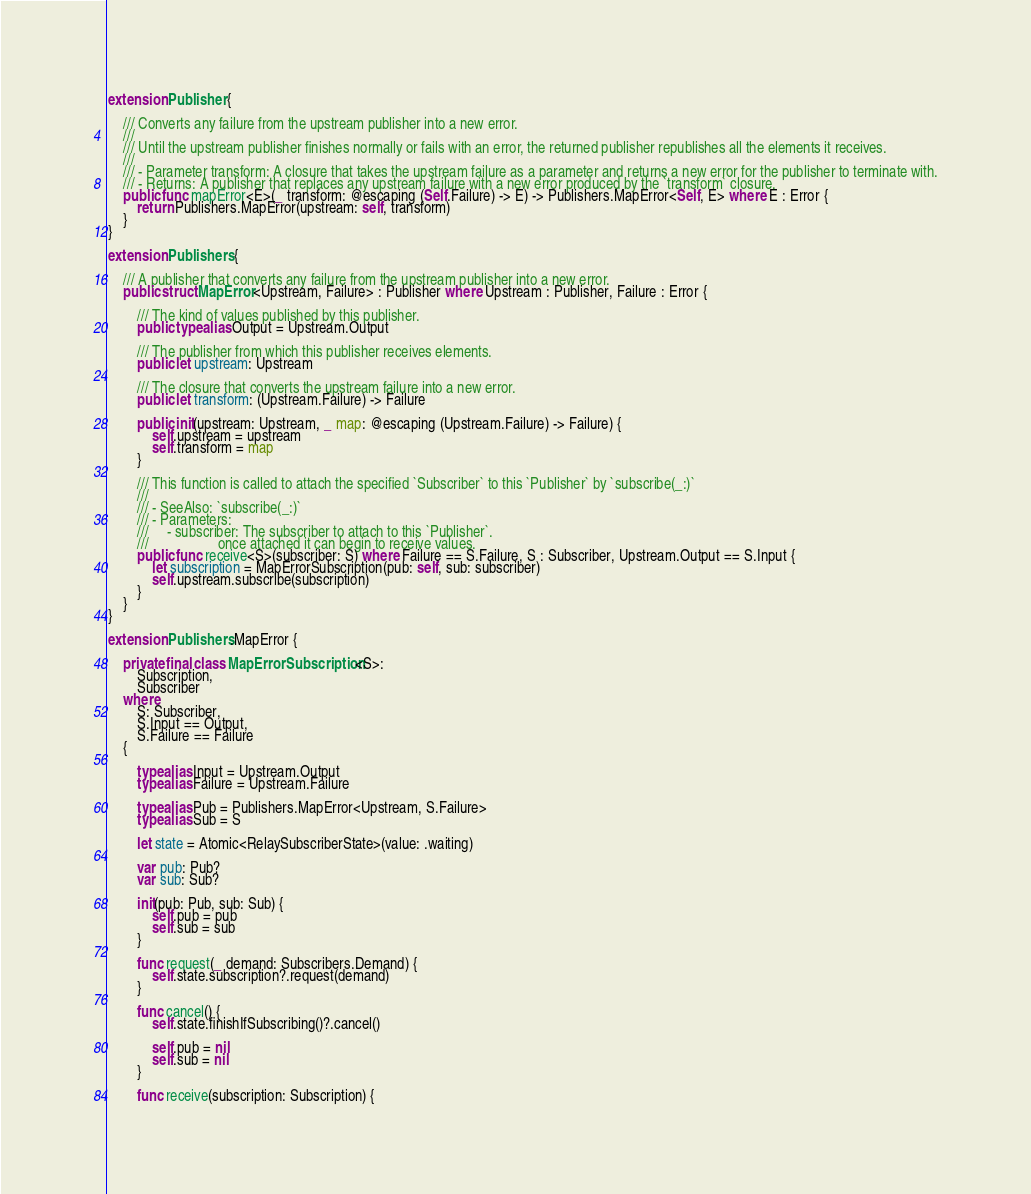<code> <loc_0><loc_0><loc_500><loc_500><_Swift_>extension Publisher {
    
    /// Converts any failure from the upstream publisher into a new error.
    ///
    /// Until the upstream publisher finishes normally or fails with an error, the returned publisher republishes all the elements it receives.
    ///
    /// - Parameter transform: A closure that takes the upstream failure as a parameter and returns a new error for the publisher to terminate with.
    /// - Returns: A publisher that replaces any upstream failure with a new error produced by the `transform` closure.
    public func mapError<E>(_ transform: @escaping (Self.Failure) -> E) -> Publishers.MapError<Self, E> where E : Error {
        return Publishers.MapError(upstream: self, transform)
    }
}

extension Publishers {
    
    /// A publisher that converts any failure from the upstream publisher into a new error.
    public struct MapError<Upstream, Failure> : Publisher where Upstream : Publisher, Failure : Error {
        
        /// The kind of values published by this publisher.
        public typealias Output = Upstream.Output
        
        /// The publisher from which this publisher receives elements.
        public let upstream: Upstream
        
        /// The closure that converts the upstream failure into a new error.
        public let transform: (Upstream.Failure) -> Failure
        
        public init(upstream: Upstream, _ map: @escaping (Upstream.Failure) -> Failure) {
            self.upstream = upstream
            self.transform = map
        }
        
        /// This function is called to attach the specified `Subscriber` to this `Publisher` by `subscribe(_:)`
        ///
        /// - SeeAlso: `subscribe(_:)`
        /// - Parameters:
        ///     - subscriber: The subscriber to attach to this `Publisher`.
        ///                   once attached it can begin to receive values.
        public func receive<S>(subscriber: S) where Failure == S.Failure, S : Subscriber, Upstream.Output == S.Input {
            let subscription = MapErrorSubscription(pub: self, sub: subscriber)
            self.upstream.subscribe(subscription)
        }
    }
}

extension Publishers.MapError {
    
    private final class MapErrorSubscription<S>:
        Subscription,
        Subscriber
    where
        S: Subscriber,
        S.Input == Output,
        S.Failure == Failure
    {
        
        typealias Input = Upstream.Output
        typealias Failure = Upstream.Failure
        
        typealias Pub = Publishers.MapError<Upstream, S.Failure>
        typealias Sub = S
        
        let state = Atomic<RelaySubscriberState>(value: .waiting)
        
        var pub: Pub?
        var sub: Sub?
        
        init(pub: Pub, sub: Sub) {
            self.pub = pub
            self.sub = sub
        }
        
        func request(_ demand: Subscribers.Demand) {
            self.state.subscription?.request(demand)
        }
        
        func cancel() {
            self.state.finishIfSubscribing()?.cancel()

            self.pub = nil
            self.sub = nil
        }
        
        func receive(subscription: Subscription) {</code> 